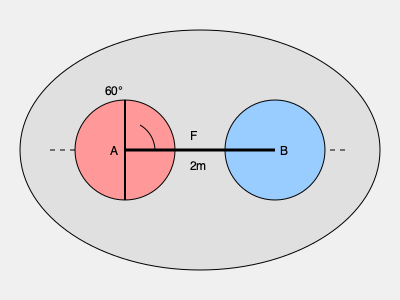In a wrestling match, Wrestler A applies a force $F$ at a 60° angle to the horizontal on Wrestler B, as shown in the diagram. If the wrestlers are 2 meters apart and Wrestler A's mass is 80 kg, calculate the magnitude of the horizontal component of the force $F$ required to maintain static equilibrium. Assume $g = 9.8 \text{ m/s}^2$ and neglect friction. To solve this problem, we'll follow these steps:

1) First, we need to understand that for static equilibrium, the sum of all forces must be zero.

2) The force $F$ can be decomposed into horizontal and vertical components:
   $F_x = F \cos 60°$
   $F_y = F \sin 60°$

3) For horizontal equilibrium, we only need to consider $F_x$, as there are no other horizontal forces.

4) For vertical equilibrium, $F_y$ must equal the weight of Wrestler A:
   $F_y = F \sin 60° = mg = 80 \text{ kg} \times 9.8 \text{ m/s}^2 = 784 \text{ N}$

5) Now we can calculate $F$:
   $F = \frac{F_y}{\sin 60°} = \frac{784 \text{ N}}{\sin 60°} = 905.1 \text{ N}$

6) Finally, we can calculate the horizontal component $F_x$:
   $F_x = F \cos 60° = 905.1 \text{ N} \times \cos 60° = 452.55 \text{ N}$

Therefore, the magnitude of the horizontal component of force $F$ required to maintain static equilibrium is approximately 452.55 N.
Answer: 452.55 N 